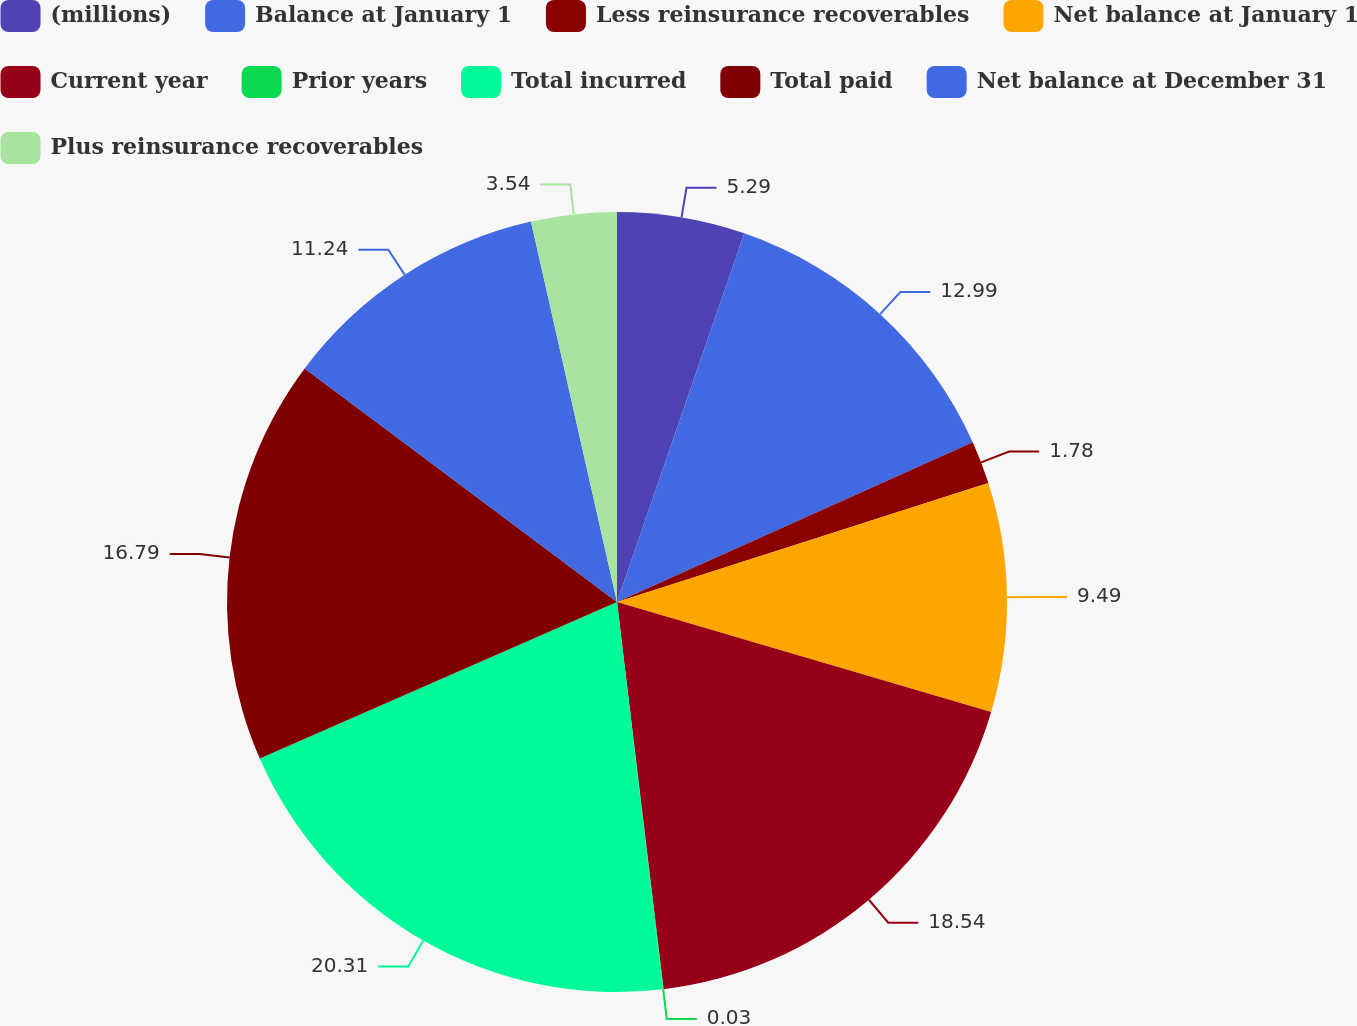<chart> <loc_0><loc_0><loc_500><loc_500><pie_chart><fcel>(millions)<fcel>Balance at January 1<fcel>Less reinsurance recoverables<fcel>Net balance at January 1<fcel>Current year<fcel>Prior years<fcel>Total incurred<fcel>Total paid<fcel>Net balance at December 31<fcel>Plus reinsurance recoverables<nl><fcel>5.29%<fcel>12.99%<fcel>1.78%<fcel>9.49%<fcel>18.54%<fcel>0.03%<fcel>20.3%<fcel>16.79%<fcel>11.24%<fcel>3.54%<nl></chart> 